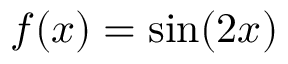<formula> <loc_0><loc_0><loc_500><loc_500>f ( x ) = \sin ( 2 x )</formula> 